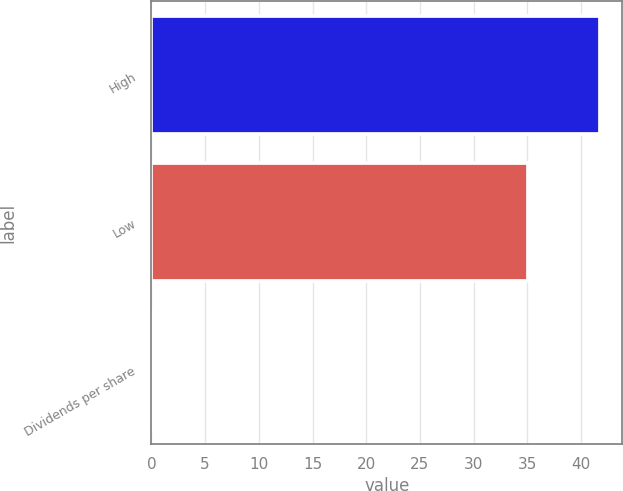Convert chart to OTSL. <chart><loc_0><loc_0><loc_500><loc_500><bar_chart><fcel>High<fcel>Low<fcel>Dividends per share<nl><fcel>41.76<fcel>35.03<fcel>0.1<nl></chart> 